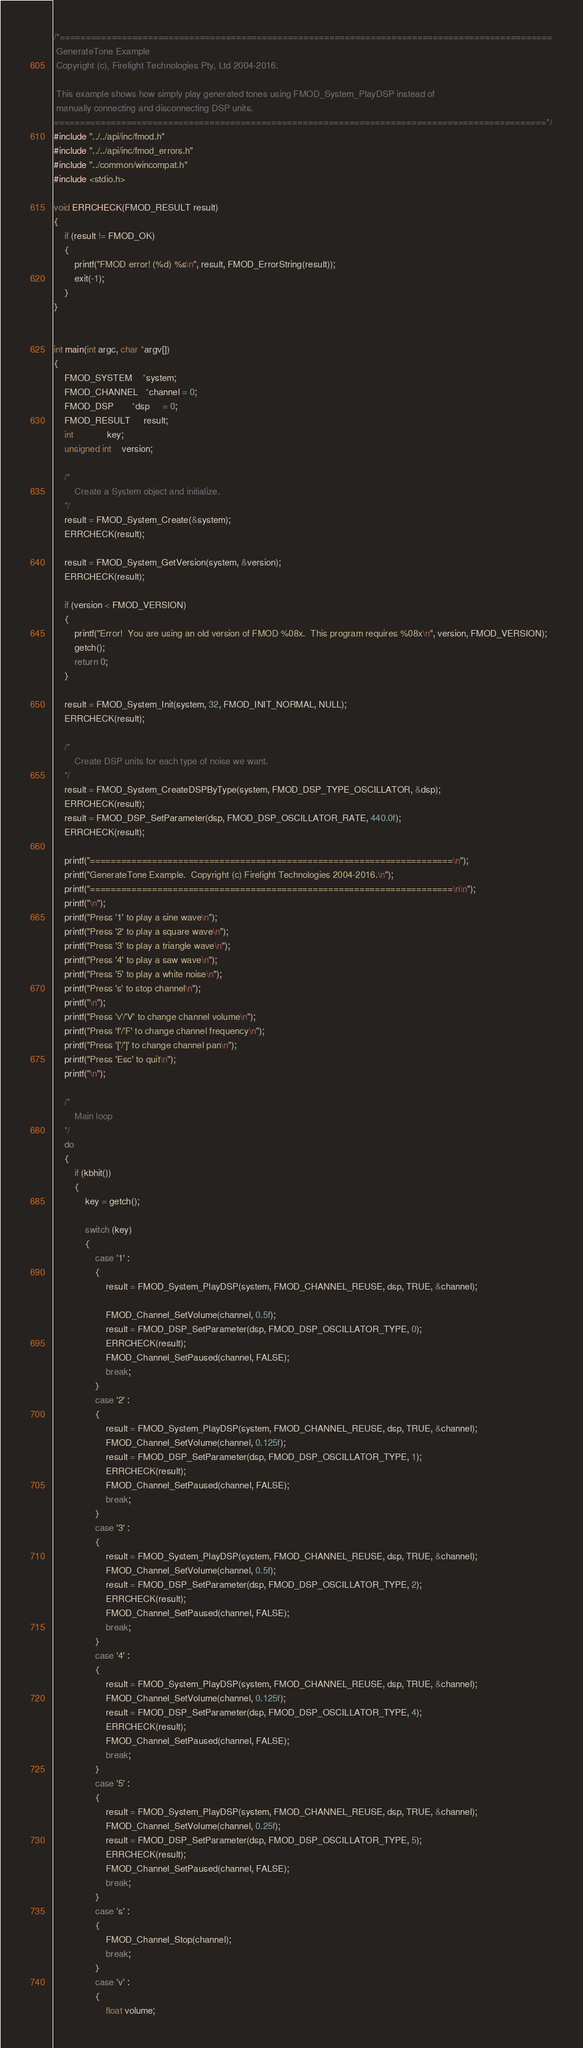<code> <loc_0><loc_0><loc_500><loc_500><_C_>/*===============================================================================================
 GenerateTone Example
 Copyright (c), Firelight Technologies Pty, Ltd 2004-2016.

 This example shows how simply play generated tones using FMOD_System_PlayDSP instead of 
 manually connecting and disconnecting DSP units.
===============================================================================================*/
#include "../../api/inc/fmod.h"
#include "../../api/inc/fmod_errors.h"
#include "../common/wincompat.h"
#include <stdio.h>

void ERRCHECK(FMOD_RESULT result)
{
    if (result != FMOD_OK)
    {
        printf("FMOD error! (%d) %s\n", result, FMOD_ErrorString(result));
        exit(-1);
    }
}


int main(int argc, char *argv[])
{
    FMOD_SYSTEM    *system;
    FMOD_CHANNEL   *channel = 0;
    FMOD_DSP       *dsp     = 0;
    FMOD_RESULT     result;
    int             key;
    unsigned int    version;

    /*
        Create a System object and initialize.
    */
    result = FMOD_System_Create(&system);
    ERRCHECK(result);

    result = FMOD_System_GetVersion(system, &version);
    ERRCHECK(result);

    if (version < FMOD_VERSION)
    {
        printf("Error!  You are using an old version of FMOD %08x.  This program requires %08x\n", version, FMOD_VERSION);
        getch();
        return 0;
    }

    result = FMOD_System_Init(system, 32, FMOD_INIT_NORMAL, NULL);
    ERRCHECK(result);

    /*
        Create DSP units for each type of noise we want.
    */
    result = FMOD_System_CreateDSPByType(system, FMOD_DSP_TYPE_OSCILLATOR, &dsp);
    ERRCHECK(result);
    result = FMOD_DSP_SetParameter(dsp, FMOD_DSP_OSCILLATOR_RATE, 440.0f);
    ERRCHECK(result);

    printf("======================================================================\n");
    printf("GenerateTone Example.  Copyright (c) Firelight Technologies 2004-2016.\n");
    printf("======================================================================\n\n");
    printf("\n");
    printf("Press '1' to play a sine wave\n");
    printf("Press '2' to play a square wave\n");
    printf("Press '3' to play a triangle wave\n");
    printf("Press '4' to play a saw wave\n");
    printf("Press '5' to play a white noise\n");
    printf("Press 's' to stop channel\n");
    printf("\n");
    printf("Press 'v'/'V' to change channel volume\n");
    printf("Press 'f'/'F' to change channel frequency\n");
    printf("Press '['/']' to change channel pan\n");
    printf("Press 'Esc' to quit\n");
    printf("\n");

    /*
        Main loop
    */
    do
    {
        if (kbhit())
        {
            key = getch();

            switch (key)
            {
                case '1' :
                {
                    result = FMOD_System_PlayDSP(system, FMOD_CHANNEL_REUSE, dsp, TRUE, &channel);
                    
                    FMOD_Channel_SetVolume(channel, 0.5f);
                    result = FMOD_DSP_SetParameter(dsp, FMOD_DSP_OSCILLATOR_TYPE, 0);
                    ERRCHECK(result);
                    FMOD_Channel_SetPaused(channel, FALSE);
                    break;
                }
                case '2' :
                {
                    result = FMOD_System_PlayDSP(system, FMOD_CHANNEL_REUSE, dsp, TRUE, &channel);
                    FMOD_Channel_SetVolume(channel, 0.125f);
                    result = FMOD_DSP_SetParameter(dsp, FMOD_DSP_OSCILLATOR_TYPE, 1);
                    ERRCHECK(result);
                    FMOD_Channel_SetPaused(channel, FALSE);
                    break;
                }
                case '3' :
                {
                    result = FMOD_System_PlayDSP(system, FMOD_CHANNEL_REUSE, dsp, TRUE, &channel);
                    FMOD_Channel_SetVolume(channel, 0.5f);
                    result = FMOD_DSP_SetParameter(dsp, FMOD_DSP_OSCILLATOR_TYPE, 2);
                    ERRCHECK(result);
                    FMOD_Channel_SetPaused(channel, FALSE);
                    break;
                }
                case '4' :
                {
                    result = FMOD_System_PlayDSP(system, FMOD_CHANNEL_REUSE, dsp, TRUE, &channel);
                    FMOD_Channel_SetVolume(channel, 0.125f);
                    result = FMOD_DSP_SetParameter(dsp, FMOD_DSP_OSCILLATOR_TYPE, 4);
                    ERRCHECK(result);
                    FMOD_Channel_SetPaused(channel, FALSE);
                    break;
                }
                case '5' :
                {
                    result = FMOD_System_PlayDSP(system, FMOD_CHANNEL_REUSE, dsp, TRUE, &channel);
                    FMOD_Channel_SetVolume(channel, 0.25f);
                    result = FMOD_DSP_SetParameter(dsp, FMOD_DSP_OSCILLATOR_TYPE, 5);
                    ERRCHECK(result);
                    FMOD_Channel_SetPaused(channel, FALSE);
                    break;
                }
                case 's' :
                {
                    FMOD_Channel_Stop(channel);
                    break;
                }
                case 'v' :
                {
                    float volume;
</code> 